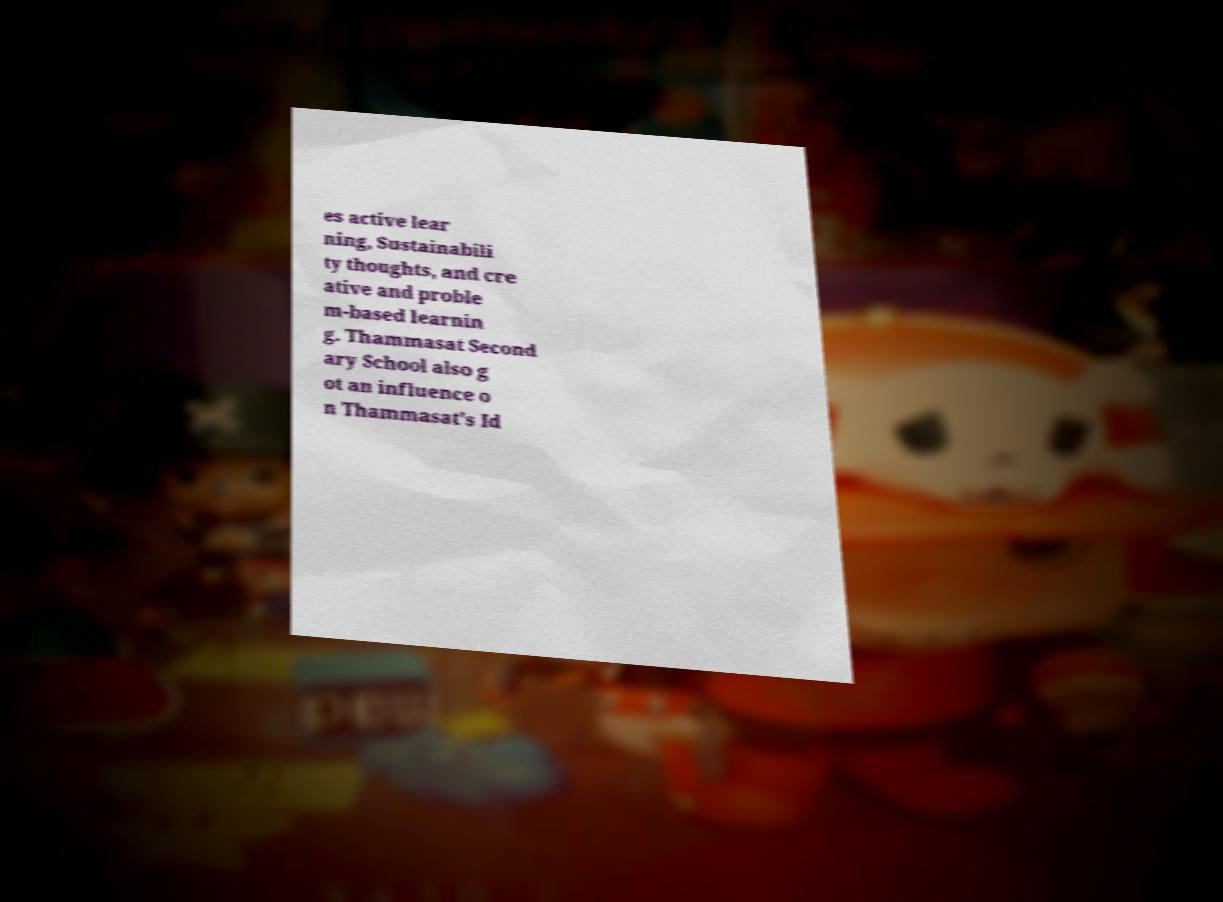Please identify and transcribe the text found in this image. es active lear ning, Sustainabili ty thoughts, and cre ative and proble m-based learnin g. Thammasat Second ary School also g ot an influence o n Thammasat's Id 